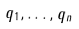Convert formula to latex. <formula><loc_0><loc_0><loc_500><loc_500>q _ { 1 } , \dots , q _ { n }</formula> 